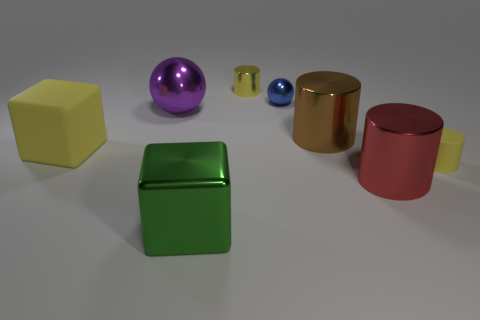Which objects in the scene reflect light most prominently? The cylinders and the purple sphere reflect light most prominently, giving them a shiny appearance, with the gold cylinder having the most reflective surface among them. What does that suggest about the material they might be made of? The reflective quality suggests that these objects could be made of a metallic or glossy plastic material, which typically have smooth surfaces that can reflect light well. 